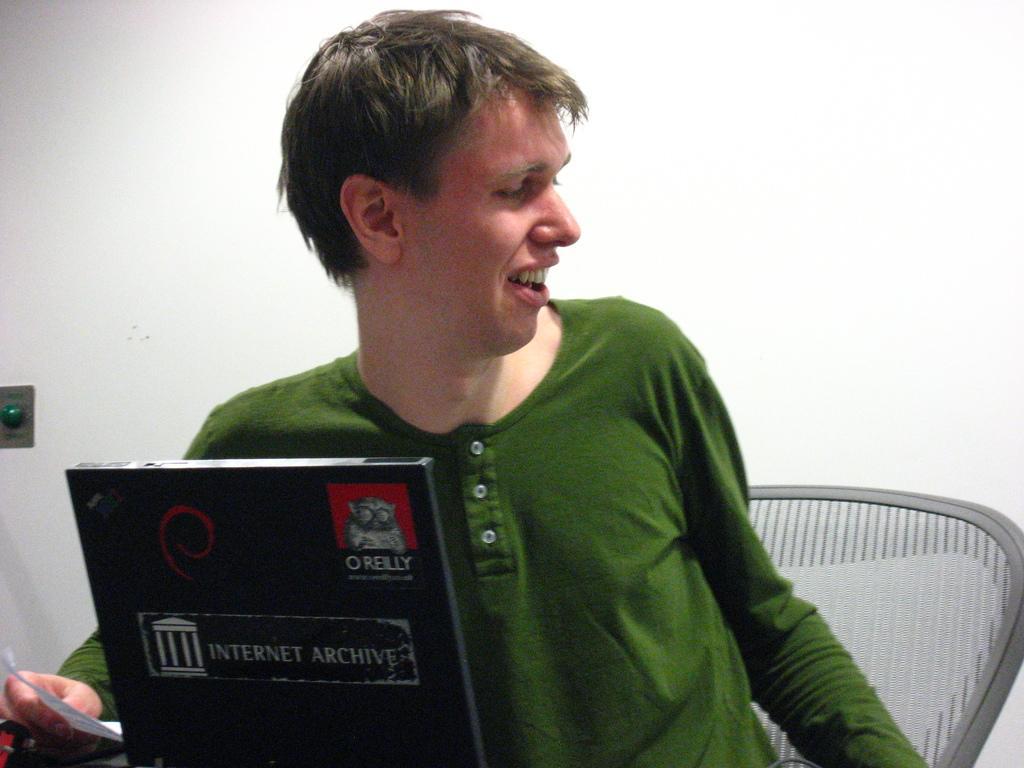Can you describe this image briefly? In the image in the center we can see one person sitting on the chair and he is smiling,which we can see on his face. And he is holding paper and he is wearing green color t shirt. In front of him,we can see black color object. In the background there is a wall. 